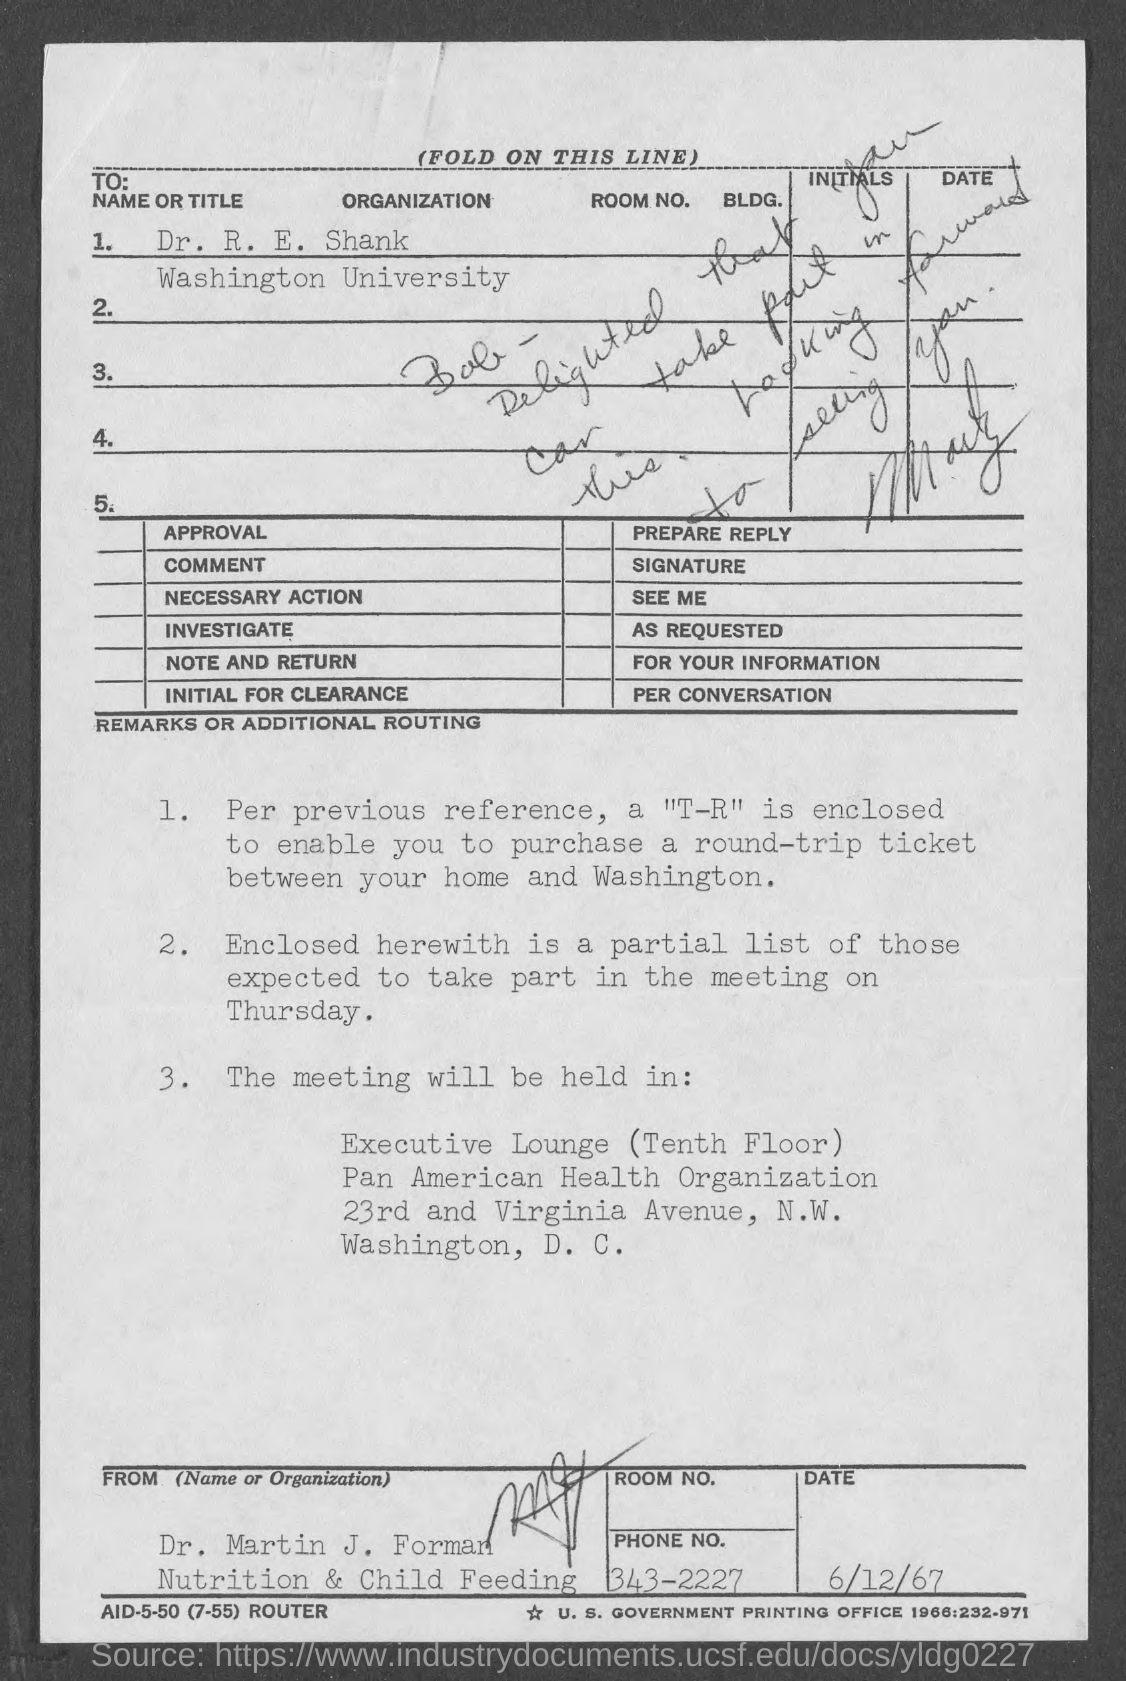List a handful of essential elements in this visual. Dr. R.E. Shank is a member of Washington University. The venue for the meeting is the Executive Lounge, which is located on the tenth floor. The Pan American Health Organization is located at 23rd and Virginia Avenue. The date at the bottom of the page is June 12th, 1967. The appropriate name or title to use for Dr. R. E. Shank is 'Dr. R. E. Shank.' 